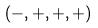Convert formula to latex. <formula><loc_0><loc_0><loc_500><loc_500>( - , + , + , + )</formula> 